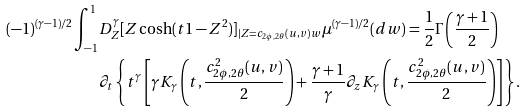Convert formula to latex. <formula><loc_0><loc_0><loc_500><loc_500>( - 1 ) ^ { ( \gamma - 1 ) / 2 } \int _ { - 1 } ^ { 1 } & D _ { Z } ^ { \gamma } [ Z \cosh ( t { 1 - Z ^ { 2 } } ) ] _ { | Z = c _ { 2 \phi , 2 \theta } ( u , v ) w } \mu ^ { ( \gamma - 1 ) / 2 } ( d w ) = \frac { 1 } { 2 } \Gamma \left ( \frac { \gamma + 1 } { 2 } \right ) \\ & \partial _ { t } \left \{ t ^ { \gamma } \left [ \gamma K _ { \gamma } \left ( t , \frac { c _ { 2 \phi , 2 \theta } ^ { 2 } ( u , v ) } { 2 } \right ) + \frac { \gamma + 1 } { \gamma } \partial _ { z } K _ { \gamma } \left ( t , \frac { c _ { 2 \phi , 2 \theta } ^ { 2 } ( u , v ) } { 2 } \right ) \right ] \right \} .</formula> 